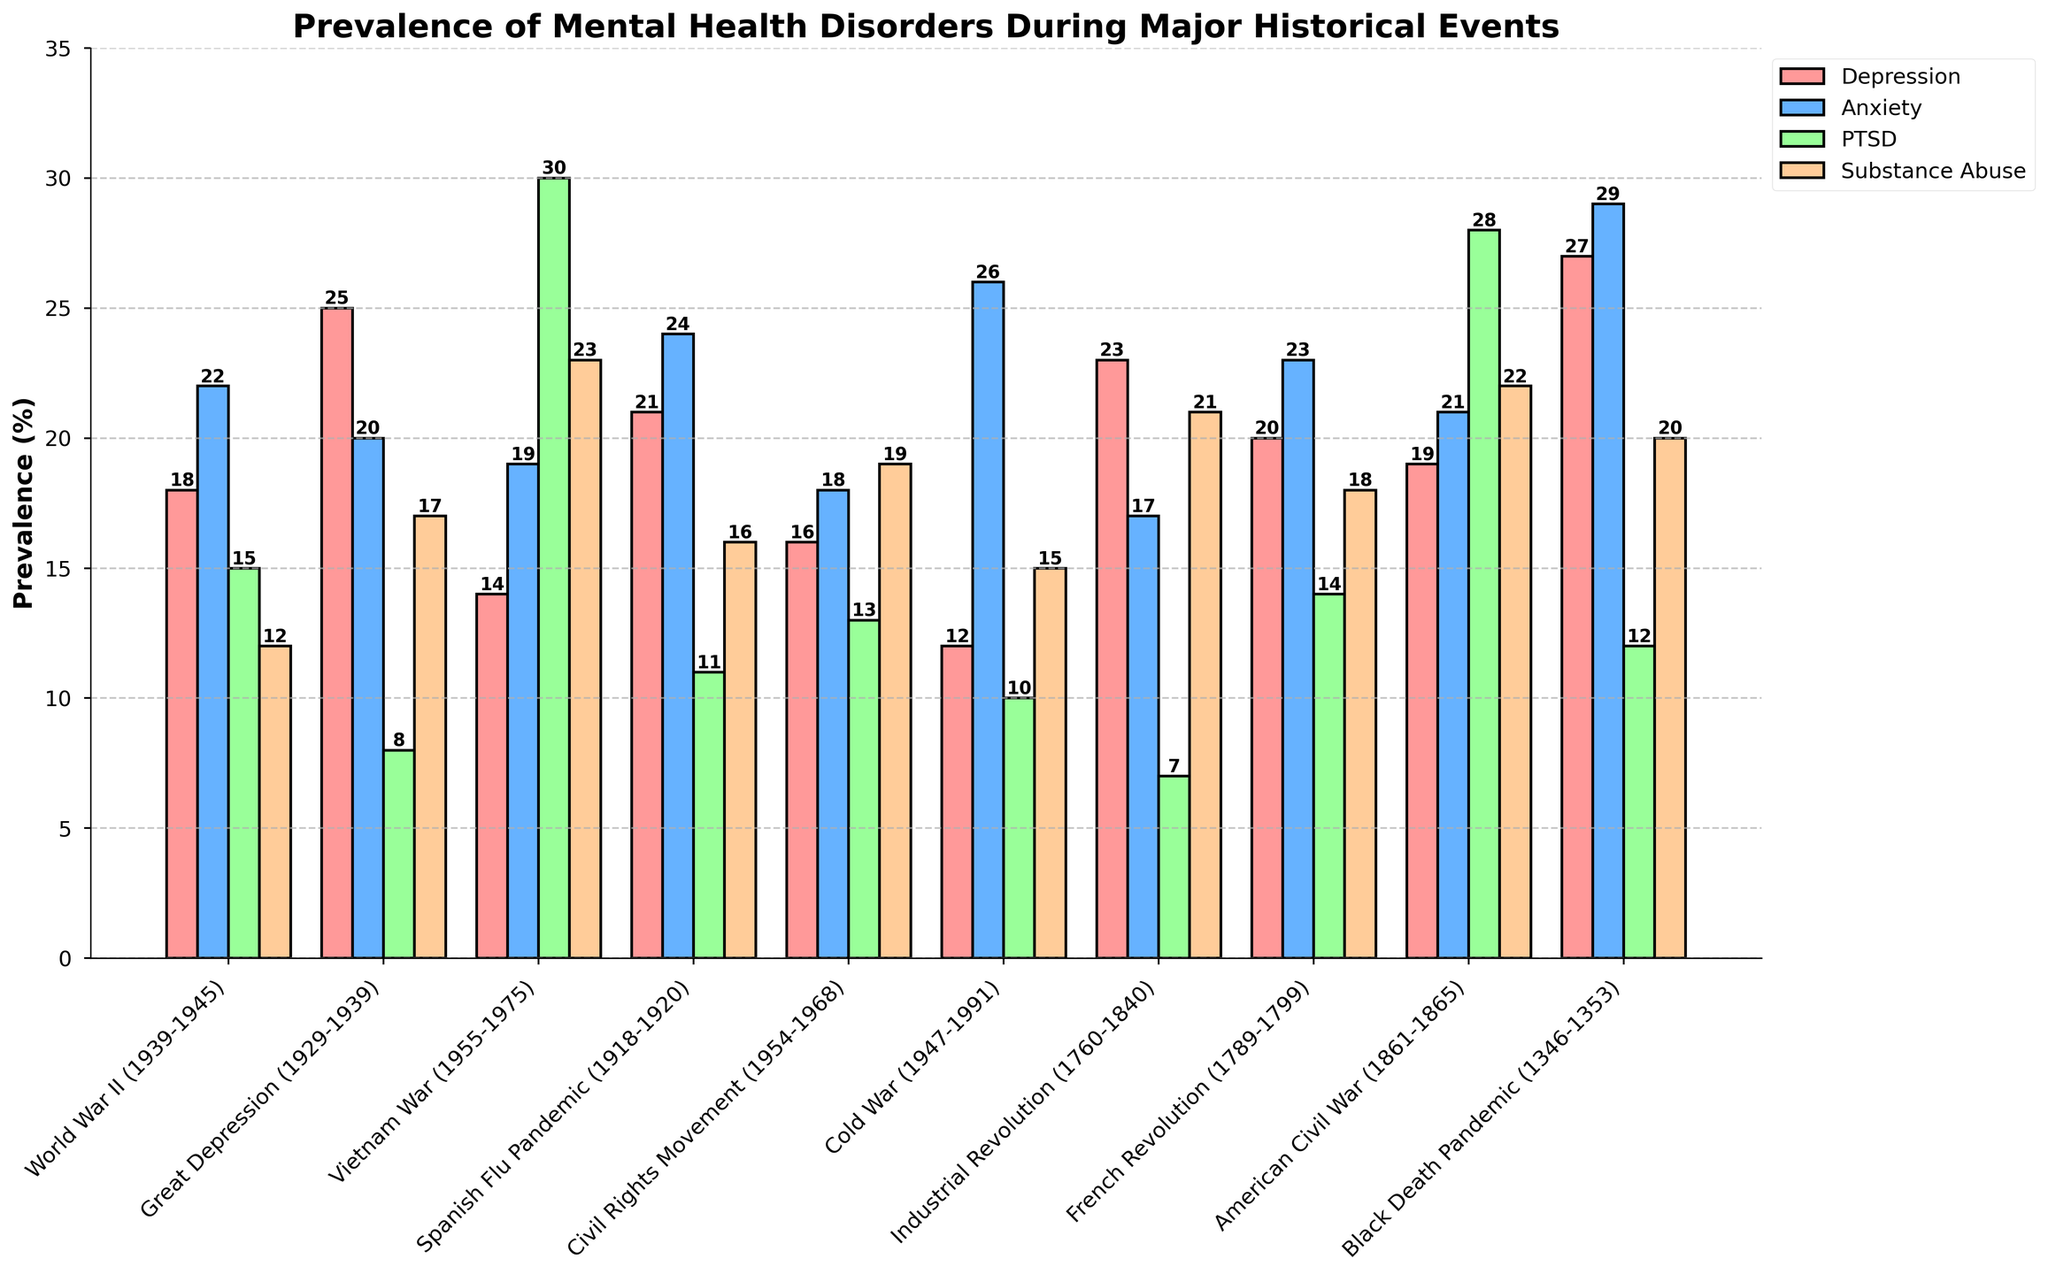Which event shows the highest prevalence of Anxiety? By looking at the height of the bars for Anxiety across all events, we notice that the bar for the Black Death Pandemic is the highest.
Answer: Black Death Pandemic What is the sum of the prevalence percentages of Depression and Substance Abuse during the Great Depression? The prevalence of Depression during the Great Depression is 25%, and for Substance Abuse, it is 17%. Adding these two values together gives us 25 + 17 = 42.
Answer: 42 Which type of disorder had the least prevalence during the Vietnam War? By comparing the heights of all bars for the Vietnam War, it is evident that Depression had the smallest bar height.
Answer: Depression How does the prevalence of PTSD during the American Civil War compare to that during the Spanish Flu Pandemic? The height of the PTSD bar for the American Civil War is 28%, and for the Spanish Flu Pandemic, it is 11%. Therefore, PTSD prevalence is higher during the American Civil War.
Answer: Higher during the American Civil War What's the average prevalence of Depression across all events? To find the average prevalence of Depression, sum all the Depression values (18 + 25 + 14 + 21 + 16 + 12 + 23 + 20 + 19 + 27 = 195), and divide by the number of events (10). So, 195 / 10 = 19.5.
Answer: 19.5 Between the Industrial Revolution and the French Revolution, which period had a higher prevalence of Substance Abuse? By examining the bar heights for Substance Abuse, we see that the Industrial Revolution had a prevalence of 21%, while the French Revolution had 18%. Therefore, Substance Abuse was higher during the Industrial Revolution.
Answer: Industrial Revolution Which disorder shows the greatest variability in prevalence across different historical events? To determine this, observe the range of heights for each disorder. Anxiety appears to have the most variation with values ranging from 17% to 29%.
Answer: Anxiety During which event was Depression more prevalent than Anxiety? By comparing the heights of the Depression and Anxiety bars within each event, we find that during the Great Depression (25% vs. 20%), Industrial Revolution (23% vs. 17%), and Black Death Pandemic (27% vs. 29%), Depression had higher values.
Answer: Great Depression and Industrial Revolution What is the difference in PTSD prevalence between World War II and the Vietnam War? The PTSD prevalence during World War II is 15%, and during the Vietnam War, it is 30%. The difference is 30 - 15 = 15.
Answer: 15 Which event had both Anxiety and Substance Abuse greater than 20%? By checking the bar heights for Anxiety and Substance Abuse across all events, we find that the Vietnam War (19% Anxiety but 23% Substance Abuse) and Black Death Pandemic (29% Anxiety and 20% Substance Abuse) fit the criteria. Therefore, the Black Death Pandemic is the event.
Answer: Black Death Pandemic 